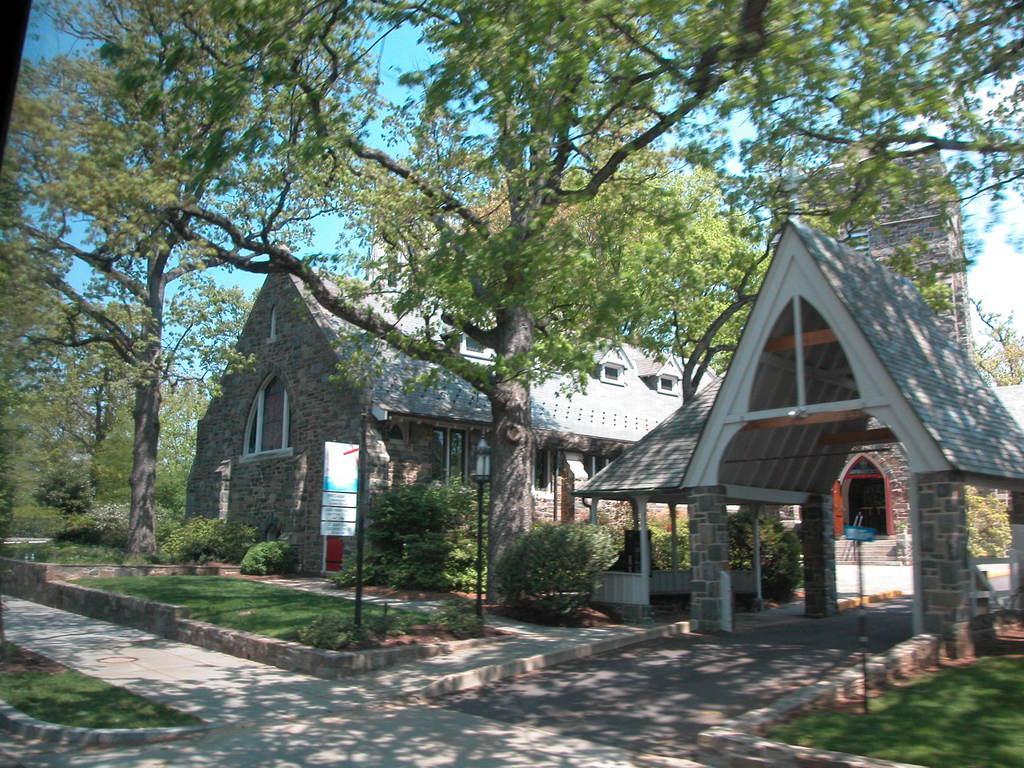Please provide a concise description of this image. On the left side, there is a road. Beside this road, there is a divider, on which there is grass. On the right side, there are buildings, trees and grass on the ground. In the background, there are clouds in the blue sky. 